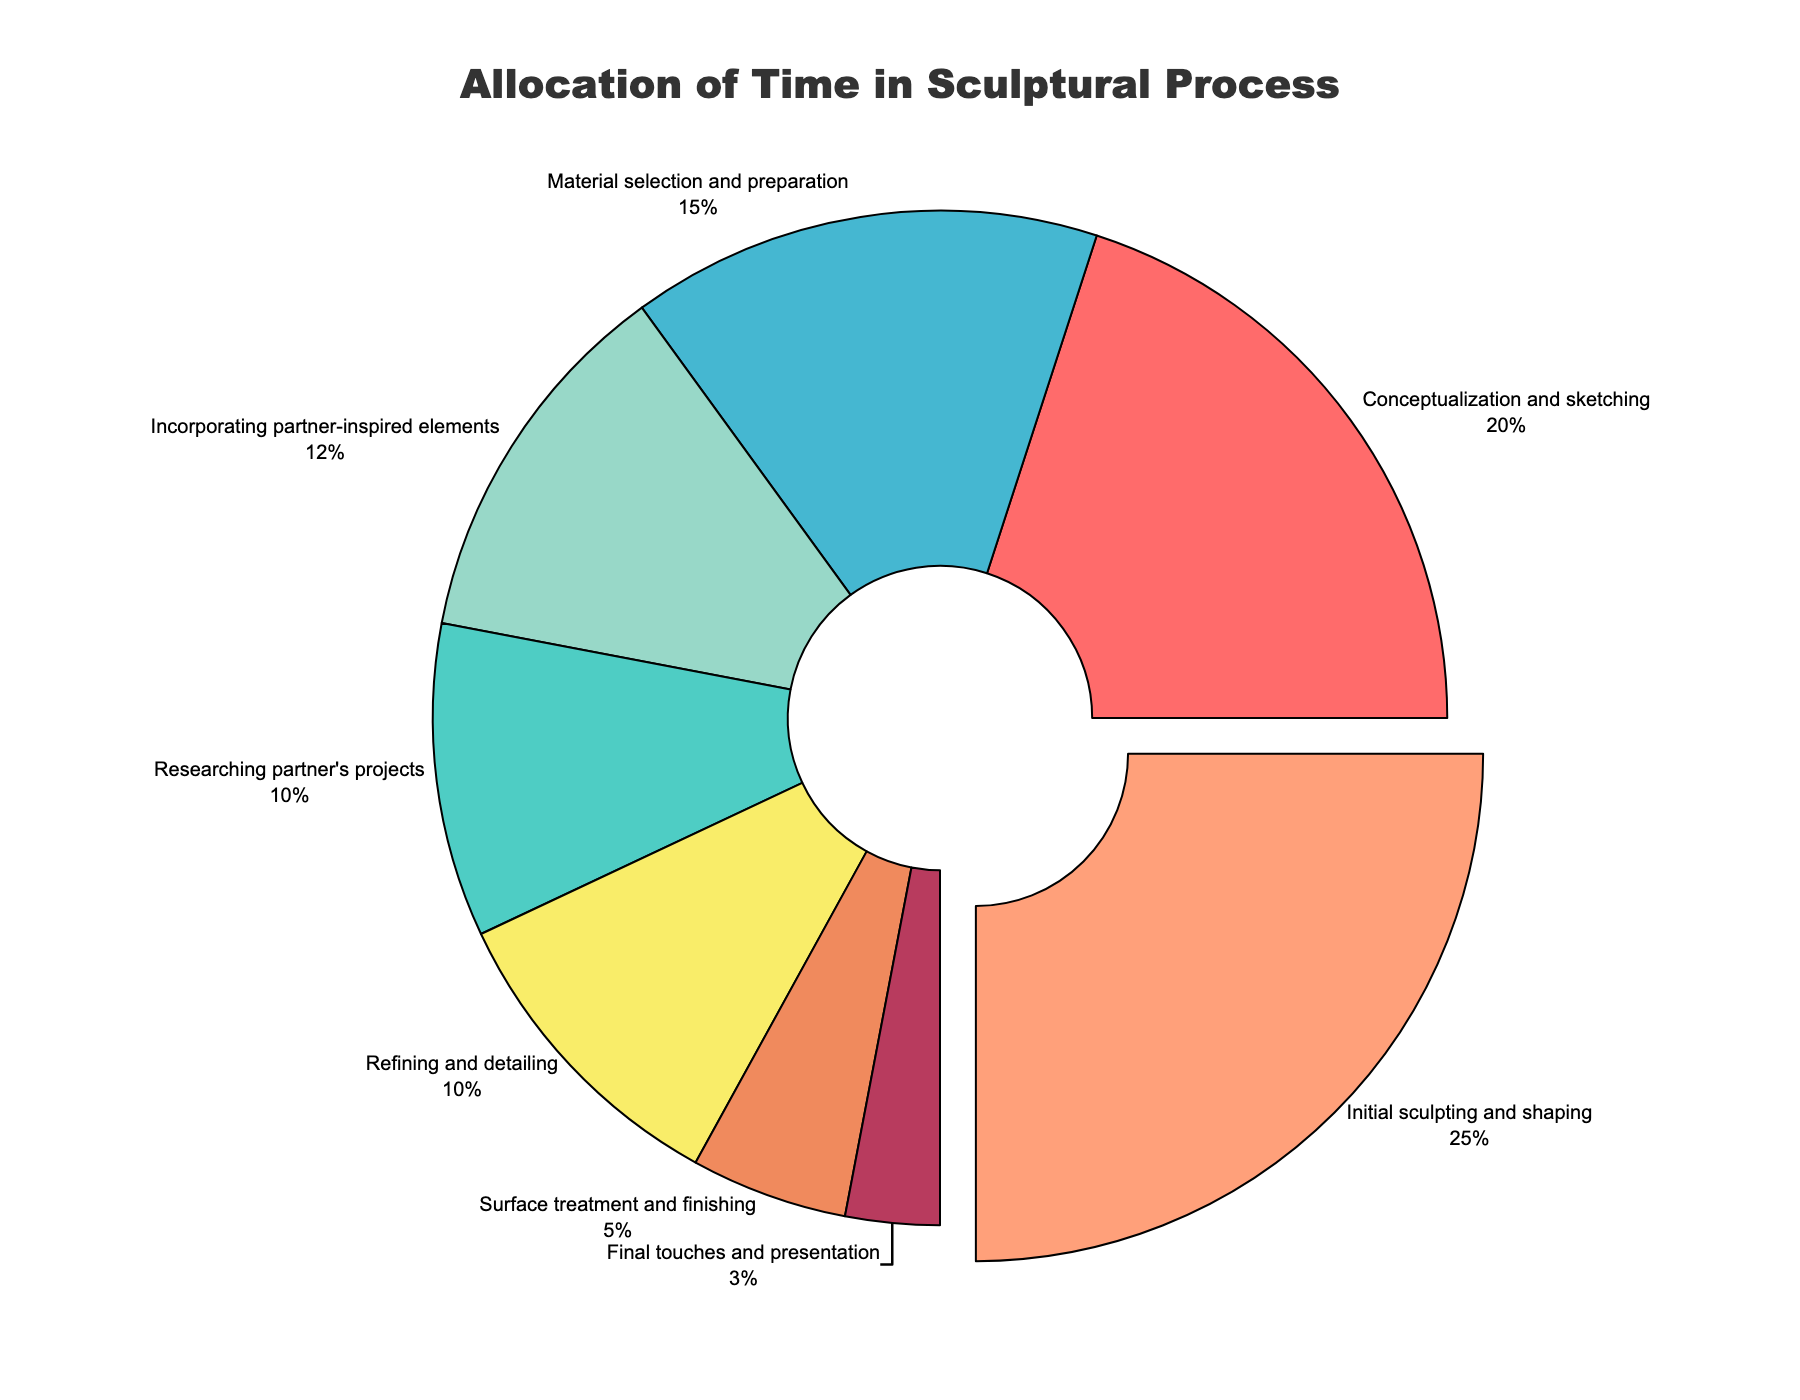What stage takes the most significant proportion of time? The largest segment of the pie chart identifies the stage with the highest percentage allocated. This is labeled "Initial sculpting and shaping" and is further emphasized by being slightly pulled out from the rest of the chart.
Answer: Initial sculpting and shaping Which stage is allocated the least time? The smallest segment of the pie chart identifies the stage with the least percentage allocated. This is labeled "Final touches and presentation."
Answer: Final touches and presentation How much time is spent incorporating partner-inspired elements compared to researching partner's projects? Comparing the two percentages, "Incorporating partner-inspired elements" is 12%, and "Researching partner's projects" is 10%. Therefore, more time is spent incorporating partner-inspired elements.
Answer: 12% vs 10% What percentage of time is spent in the stages 'Initial sculpting and shaping' and 'Material selection and preparation' combined? Add the percentages for "Initial sculpting and shaping" (25%) and "Material selection and preparation" (15%). The total is 25% + 15% = 40%.
Answer: 40% Is the percentage of time spent on 'Incorporating partner-inspired elements' greater than that on 'Refining and detailing'? Compare the two percentages, "Incorporating partner-inspired elements" is 12%, and "Refining and detailing" is 10%. 12% is indeed greater than 10%.
Answer: Yes Which color represents the stage 'Surface treatment and finishing'? Identify the segment labeled "Surface treatment and finishing," and observe the color associated with it in the pie chart. This segment is typically marked in a distinctive color.
Answer: Orange What is the combined percentage for stages that involve initial planning and preparation (Conceptualization and sketching, Researching partner's projects, Material selection and preparation)? Add the percentages for "Conceptualization and sketching" (20%), "Researching partner's projects" (10%), and "Material selection and preparation" (15%). The total is 20% + 10% + 15% = 45%.
Answer: 45% Which stage has almost half the percentage of time compared to 'Initial sculpting and shaping'? "Initial sculpting and shaping" uses 25% of the time. Half of that percentage is 12.5%. The closest stage is "Incorporating partner-inspired elements" with 12%.
Answer: Incorporating partner-inspired elements 